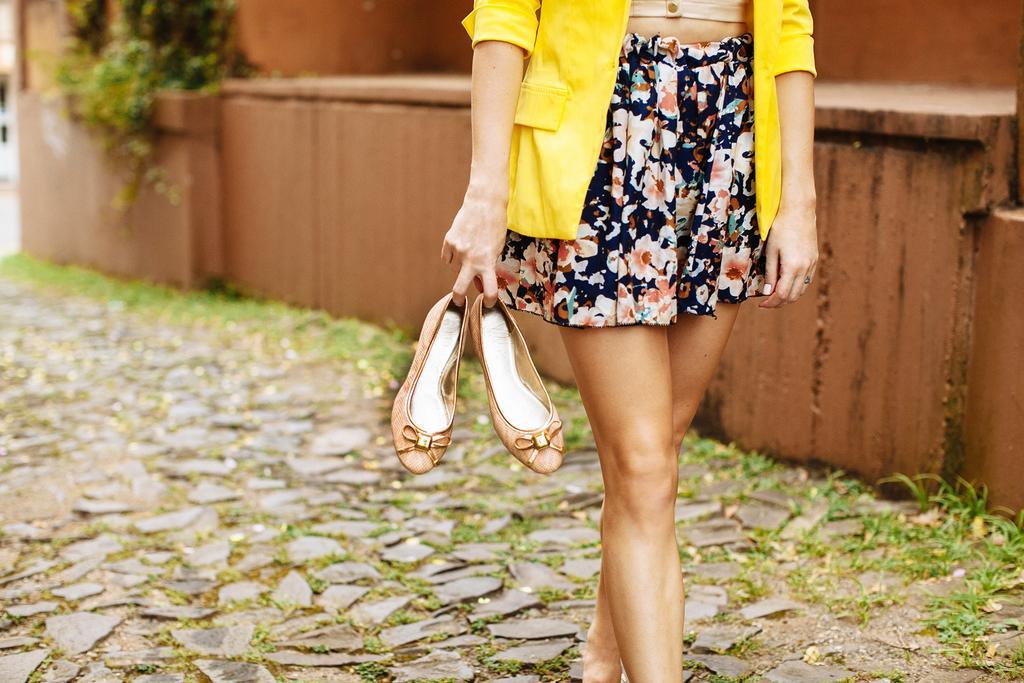Could you give a brief overview of what you see in this image? In the picture I can see a person, through face is not visible. The person is wearing a yellow color jacket and a skirt and holding footwear. I can see the wall and there are plants on the top left side of the picture. I can see the stone flooring at the bottom of the picture. 